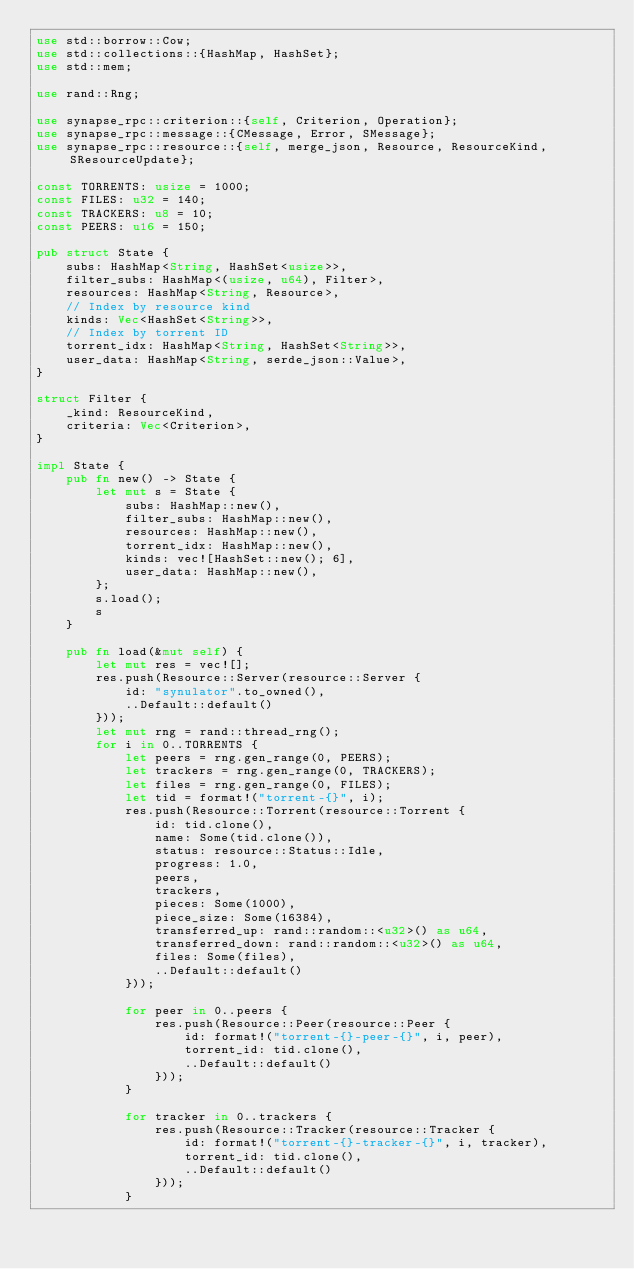Convert code to text. <code><loc_0><loc_0><loc_500><loc_500><_Rust_>use std::borrow::Cow;
use std::collections::{HashMap, HashSet};
use std::mem;

use rand::Rng;

use synapse_rpc::criterion::{self, Criterion, Operation};
use synapse_rpc::message::{CMessage, Error, SMessage};
use synapse_rpc::resource::{self, merge_json, Resource, ResourceKind, SResourceUpdate};

const TORRENTS: usize = 1000;
const FILES: u32 = 140;
const TRACKERS: u8 = 10;
const PEERS: u16 = 150;

pub struct State {
    subs: HashMap<String, HashSet<usize>>,
    filter_subs: HashMap<(usize, u64), Filter>,
    resources: HashMap<String, Resource>,
    // Index by resource kind
    kinds: Vec<HashSet<String>>,
    // Index by torrent ID
    torrent_idx: HashMap<String, HashSet<String>>,
    user_data: HashMap<String, serde_json::Value>,
}

struct Filter {
    _kind: ResourceKind,
    criteria: Vec<Criterion>,
}

impl State {
    pub fn new() -> State {
        let mut s = State {
            subs: HashMap::new(),
            filter_subs: HashMap::new(),
            resources: HashMap::new(),
            torrent_idx: HashMap::new(),
            kinds: vec![HashSet::new(); 6],
            user_data: HashMap::new(),
        };
        s.load();
        s
    }

    pub fn load(&mut self) {
        let mut res = vec![];
        res.push(Resource::Server(resource::Server {
            id: "synulator".to_owned(),
            ..Default::default()
        }));
        let mut rng = rand::thread_rng();
        for i in 0..TORRENTS {
            let peers = rng.gen_range(0, PEERS);
            let trackers = rng.gen_range(0, TRACKERS);
            let files = rng.gen_range(0, FILES);
            let tid = format!("torrent-{}", i);
            res.push(Resource::Torrent(resource::Torrent {
                id: tid.clone(),
                name: Some(tid.clone()),
                status: resource::Status::Idle,
                progress: 1.0,
                peers,
                trackers,
                pieces: Some(1000),
                piece_size: Some(16384),
                transferred_up: rand::random::<u32>() as u64,
                transferred_down: rand::random::<u32>() as u64,
                files: Some(files),
                ..Default::default()
            }));

            for peer in 0..peers {
                res.push(Resource::Peer(resource::Peer {
                    id: format!("torrent-{}-peer-{}", i, peer),
                    torrent_id: tid.clone(),
                    ..Default::default()
                }));
            }

            for tracker in 0..trackers {
                res.push(Resource::Tracker(resource::Tracker {
                    id: format!("torrent-{}-tracker-{}", i, tracker),
                    torrent_id: tid.clone(),
                    ..Default::default()
                }));
            }
</code> 